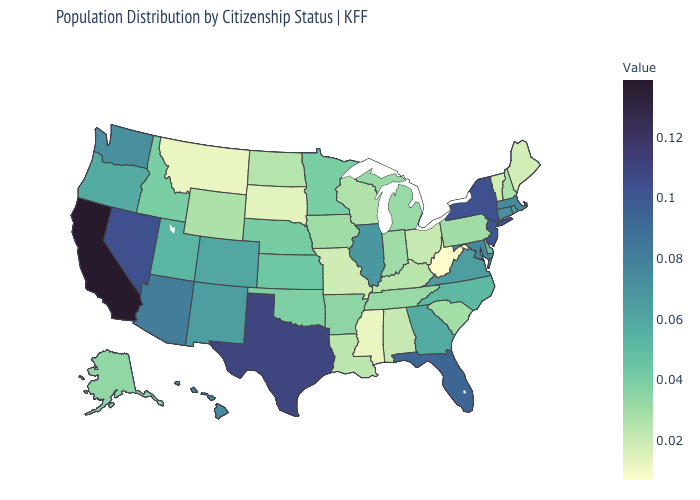Among the states that border Oregon , does Washington have the lowest value?
Concise answer only. No. Among the states that border Colorado , which have the highest value?
Short answer required. Arizona. Among the states that border Wisconsin , does Minnesota have the lowest value?
Short answer required. No. Is the legend a continuous bar?
Keep it brief. Yes. Among the states that border Vermont , does New Hampshire have the highest value?
Give a very brief answer. No. Which states have the lowest value in the West?
Short answer required. Montana. Which states hav the highest value in the South?
Answer briefly. Texas. Which states hav the highest value in the MidWest?
Short answer required. Illinois. 